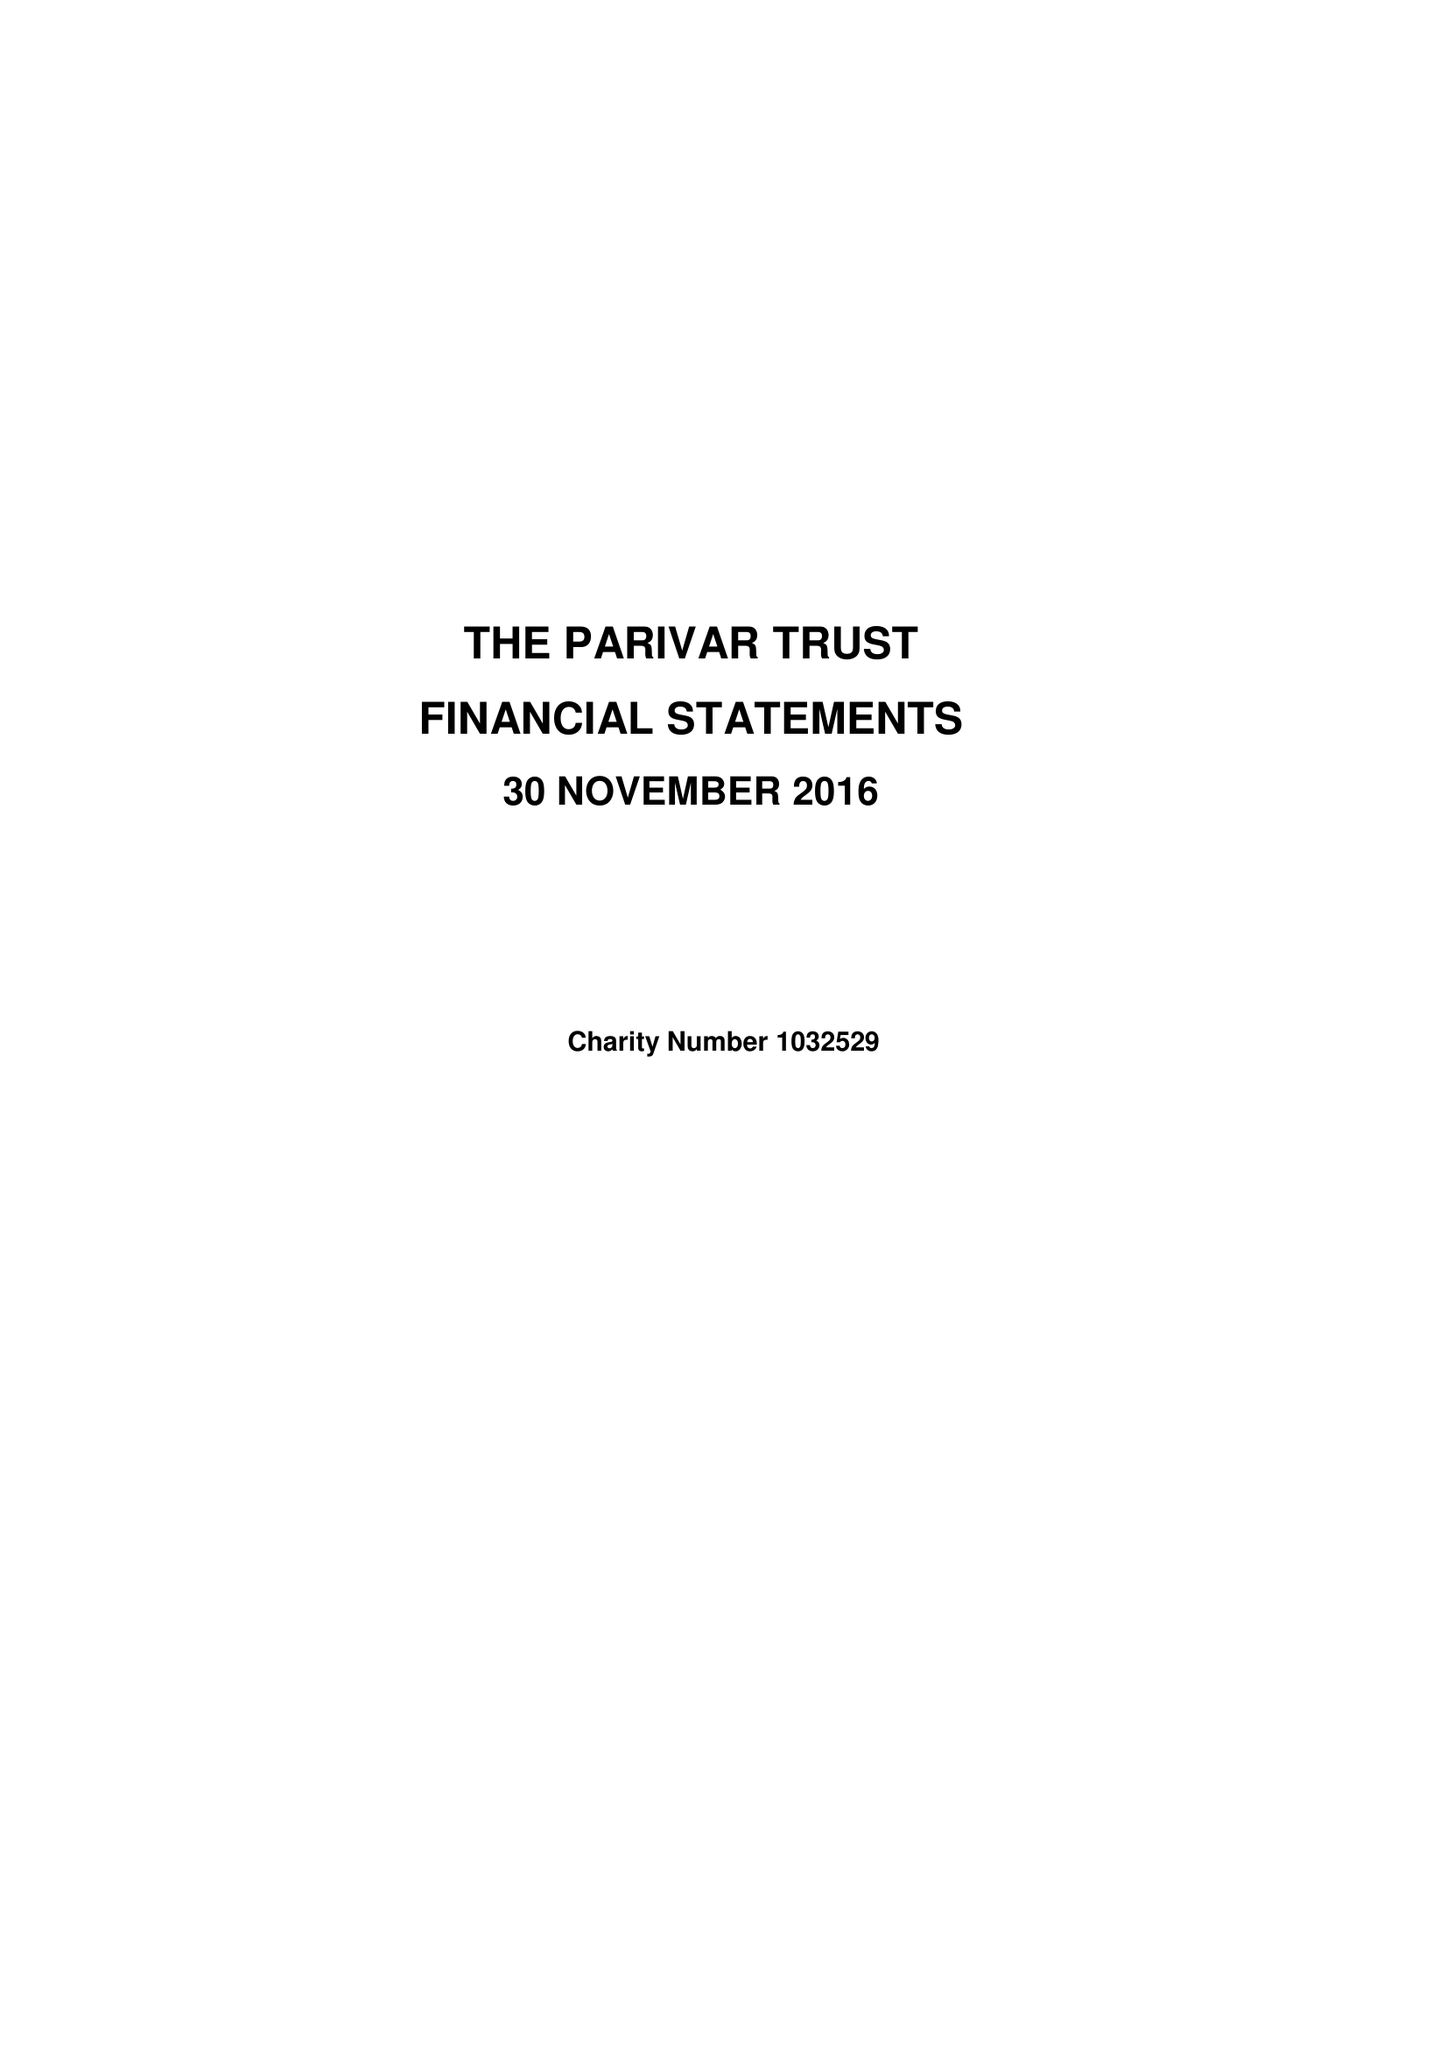What is the value for the report_date?
Answer the question using a single word or phrase. 2016-11-30 